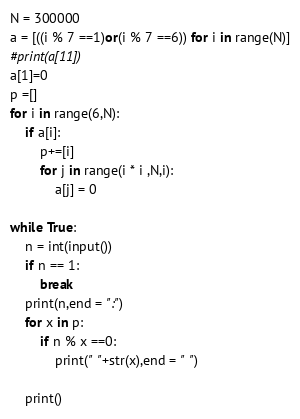Convert code to text. <code><loc_0><loc_0><loc_500><loc_500><_Python_>N = 300000
a = [((i % 7 ==1)or(i % 7 ==6)) for i in range(N)]
#print(a[11])
a[1]=0
p =[]
for i in range(6,N):
    if a[i]:
        p+=[i]
        for j in range(i * i ,N,i):
            a[j] = 0
 
while True:
    n = int(input())
    if n == 1:
        break
    print(n,end = ":")
    for x in p:
        if n % x ==0:
            print(" "+str(x),end = " ")

    print()

</code> 